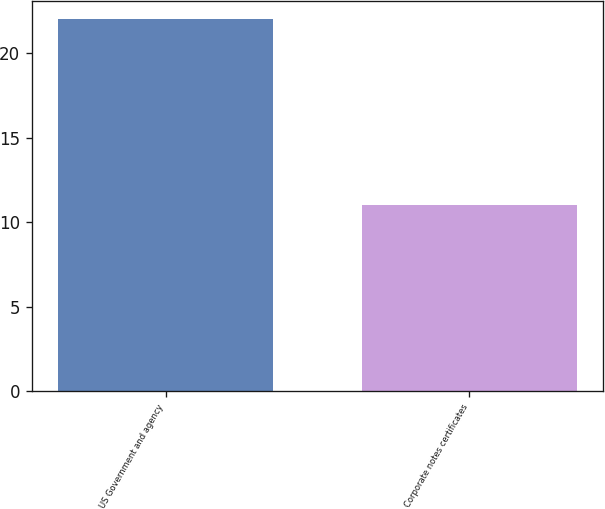Convert chart to OTSL. <chart><loc_0><loc_0><loc_500><loc_500><bar_chart><fcel>US Government and agency<fcel>Corporate notes certificates<nl><fcel>22<fcel>11<nl></chart> 